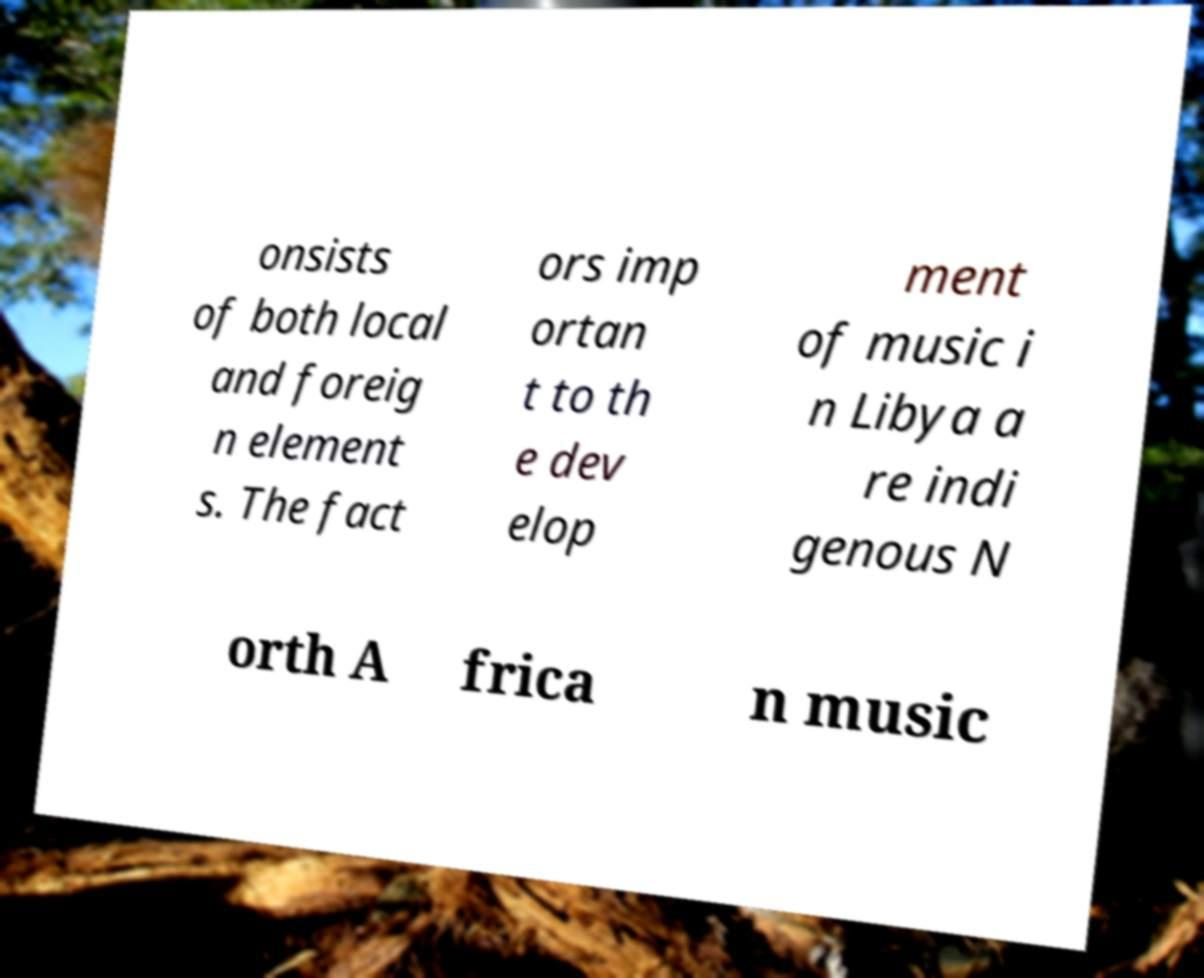There's text embedded in this image that I need extracted. Can you transcribe it verbatim? onsists of both local and foreig n element s. The fact ors imp ortan t to th e dev elop ment of music i n Libya a re indi genous N orth A frica n music 